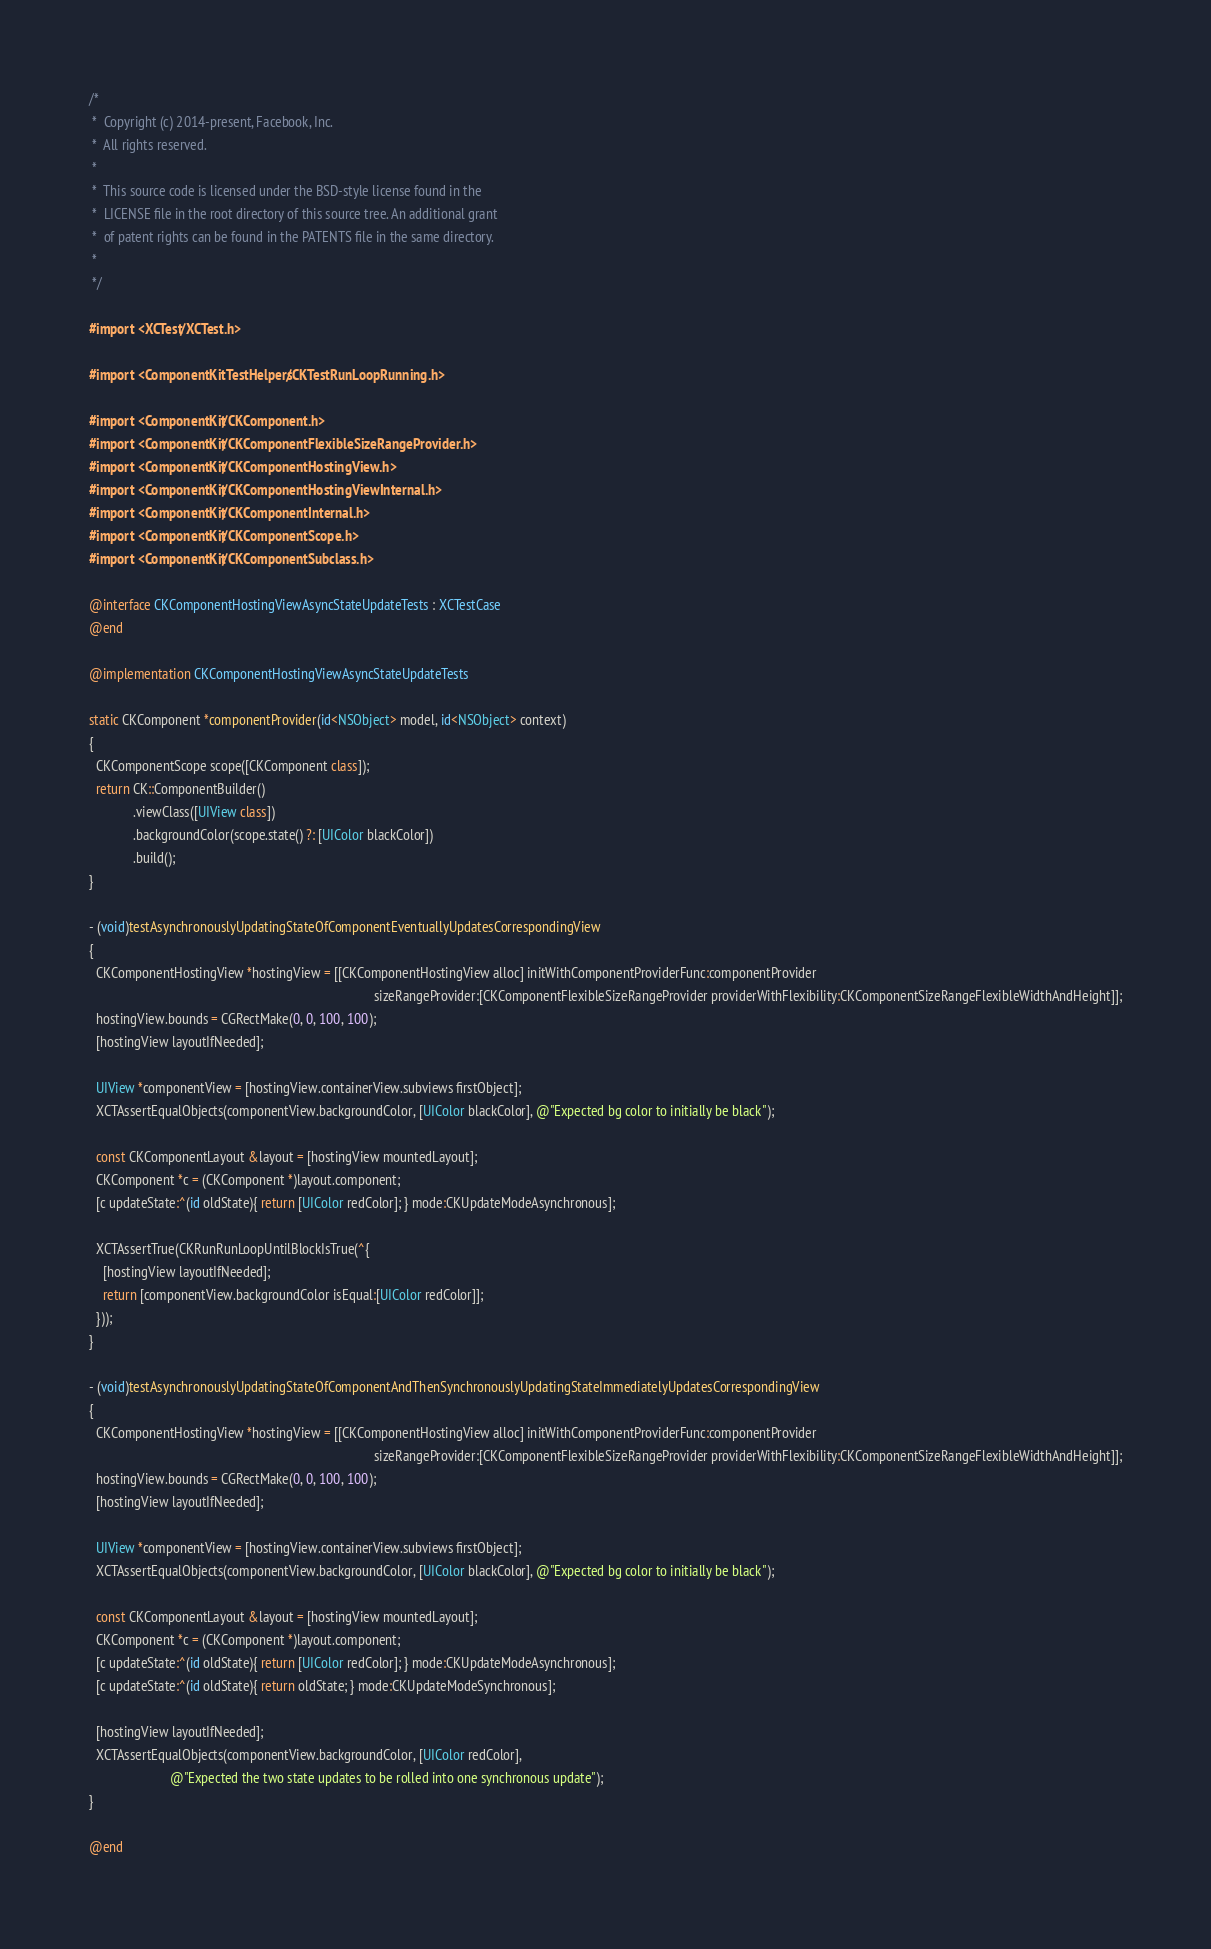<code> <loc_0><loc_0><loc_500><loc_500><_ObjectiveC_>/*
 *  Copyright (c) 2014-present, Facebook, Inc.
 *  All rights reserved.
 *
 *  This source code is licensed under the BSD-style license found in the
 *  LICENSE file in the root directory of this source tree. An additional grant
 *  of patent rights can be found in the PATENTS file in the same directory.
 *
 */

#import <XCTest/XCTest.h>

#import <ComponentKitTestHelpers/CKTestRunLoopRunning.h>

#import <ComponentKit/CKComponent.h>
#import <ComponentKit/CKComponentFlexibleSizeRangeProvider.h>
#import <ComponentKit/CKComponentHostingView.h>
#import <ComponentKit/CKComponentHostingViewInternal.h>
#import <ComponentKit/CKComponentInternal.h>
#import <ComponentKit/CKComponentScope.h>
#import <ComponentKit/CKComponentSubclass.h>

@interface CKComponentHostingViewAsyncStateUpdateTests : XCTestCase 
@end

@implementation CKComponentHostingViewAsyncStateUpdateTests

static CKComponent *componentProvider(id<NSObject> model, id<NSObject> context)
{
  CKComponentScope scope([CKComponent class]);
  return CK::ComponentBuilder()
             .viewClass([UIView class])
             .backgroundColor(scope.state() ?: [UIColor blackColor])
             .build();
}

- (void)testAsynchronouslyUpdatingStateOfComponentEventuallyUpdatesCorrespondingView
{
  CKComponentHostingView *hostingView = [[CKComponentHostingView alloc] initWithComponentProviderFunc:componentProvider
                                                                                    sizeRangeProvider:[CKComponentFlexibleSizeRangeProvider providerWithFlexibility:CKComponentSizeRangeFlexibleWidthAndHeight]];
  hostingView.bounds = CGRectMake(0, 0, 100, 100);
  [hostingView layoutIfNeeded];

  UIView *componentView = [hostingView.containerView.subviews firstObject];
  XCTAssertEqualObjects(componentView.backgroundColor, [UIColor blackColor], @"Expected bg color to initially be black");

  const CKComponentLayout &layout = [hostingView mountedLayout];
  CKComponent *c = (CKComponent *)layout.component;
  [c updateState:^(id oldState){ return [UIColor redColor]; } mode:CKUpdateModeAsynchronous];

  XCTAssertTrue(CKRunRunLoopUntilBlockIsTrue(^{
    [hostingView layoutIfNeeded];
    return [componentView.backgroundColor isEqual:[UIColor redColor]];
  }));
}

- (void)testAsynchronouslyUpdatingStateOfComponentAndThenSynchronouslyUpdatingStateImmediatelyUpdatesCorrespondingView
{
  CKComponentHostingView *hostingView = [[CKComponentHostingView alloc] initWithComponentProviderFunc:componentProvider
                                                                                    sizeRangeProvider:[CKComponentFlexibleSizeRangeProvider providerWithFlexibility:CKComponentSizeRangeFlexibleWidthAndHeight]];
  hostingView.bounds = CGRectMake(0, 0, 100, 100);
  [hostingView layoutIfNeeded];

  UIView *componentView = [hostingView.containerView.subviews firstObject];
  XCTAssertEqualObjects(componentView.backgroundColor, [UIColor blackColor], @"Expected bg color to initially be black");

  const CKComponentLayout &layout = [hostingView mountedLayout];
  CKComponent *c = (CKComponent *)layout.component;
  [c updateState:^(id oldState){ return [UIColor redColor]; } mode:CKUpdateModeAsynchronous];
  [c updateState:^(id oldState){ return oldState; } mode:CKUpdateModeSynchronous];

  [hostingView layoutIfNeeded];
  XCTAssertEqualObjects(componentView.backgroundColor, [UIColor redColor],
                        @"Expected the two state updates to be rolled into one synchronous update");
}

@end
</code> 